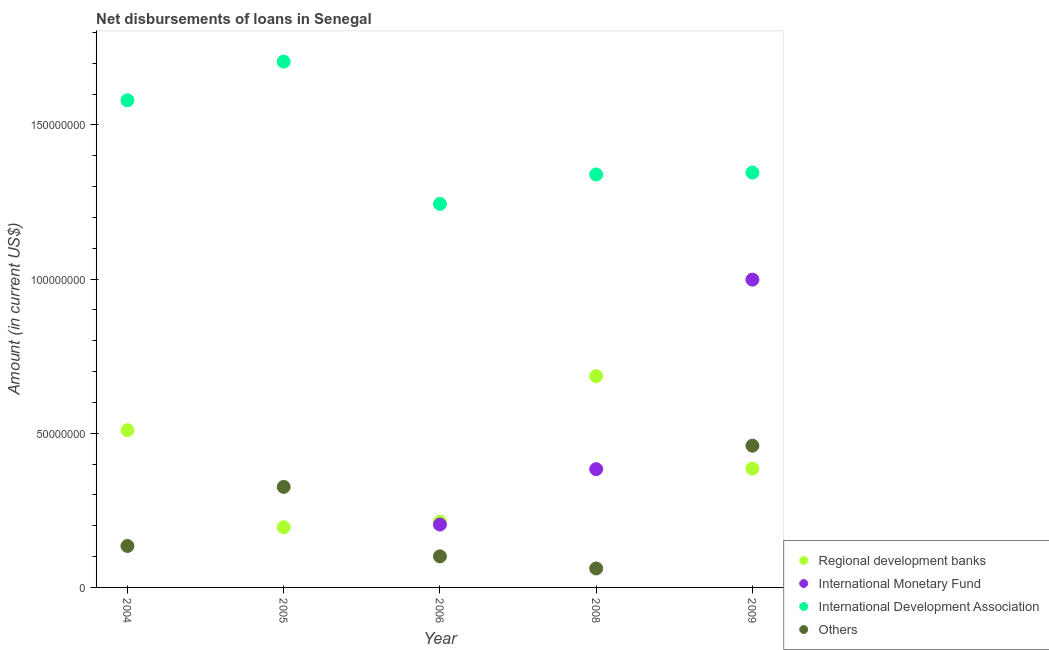What is the amount of loan disimbursed by international development association in 2008?
Ensure brevity in your answer.  1.34e+08. Across all years, what is the maximum amount of loan disimbursed by international development association?
Your answer should be compact. 1.71e+08. Across all years, what is the minimum amount of loan disimbursed by regional development banks?
Ensure brevity in your answer.  1.95e+07. In which year was the amount of loan disimbursed by international monetary fund maximum?
Ensure brevity in your answer.  2009. What is the total amount of loan disimbursed by other organisations in the graph?
Give a very brief answer. 1.08e+08. What is the difference between the amount of loan disimbursed by regional development banks in 2004 and that in 2008?
Offer a terse response. -1.75e+07. What is the difference between the amount of loan disimbursed by international monetary fund in 2006 and the amount of loan disimbursed by regional development banks in 2005?
Provide a short and direct response. 8.76e+05. What is the average amount of loan disimbursed by international development association per year?
Give a very brief answer. 1.44e+08. In the year 2006, what is the difference between the amount of loan disimbursed by other organisations and amount of loan disimbursed by international development association?
Offer a very short reply. -1.14e+08. What is the ratio of the amount of loan disimbursed by regional development banks in 2005 to that in 2006?
Ensure brevity in your answer.  0.92. Is the amount of loan disimbursed by international development association in 2005 less than that in 2008?
Give a very brief answer. No. Is the difference between the amount of loan disimbursed by other organisations in 2006 and 2008 greater than the difference between the amount of loan disimbursed by regional development banks in 2006 and 2008?
Your response must be concise. Yes. What is the difference between the highest and the second highest amount of loan disimbursed by other organisations?
Provide a short and direct response. 1.34e+07. What is the difference between the highest and the lowest amount of loan disimbursed by other organisations?
Your response must be concise. 3.98e+07. Is the amount of loan disimbursed by international development association strictly greater than the amount of loan disimbursed by other organisations over the years?
Keep it short and to the point. Yes. How many dotlines are there?
Provide a short and direct response. 4. Are the values on the major ticks of Y-axis written in scientific E-notation?
Give a very brief answer. No. Does the graph contain any zero values?
Ensure brevity in your answer.  Yes. Does the graph contain grids?
Ensure brevity in your answer.  No. Where does the legend appear in the graph?
Provide a succinct answer. Bottom right. How many legend labels are there?
Ensure brevity in your answer.  4. How are the legend labels stacked?
Offer a very short reply. Vertical. What is the title of the graph?
Give a very brief answer. Net disbursements of loans in Senegal. Does "Coal" appear as one of the legend labels in the graph?
Provide a short and direct response. No. What is the Amount (in current US$) of Regional development banks in 2004?
Provide a short and direct response. 5.10e+07. What is the Amount (in current US$) in International Development Association in 2004?
Provide a succinct answer. 1.58e+08. What is the Amount (in current US$) of Others in 2004?
Your answer should be very brief. 1.34e+07. What is the Amount (in current US$) of Regional development banks in 2005?
Your answer should be very brief. 1.95e+07. What is the Amount (in current US$) of International Development Association in 2005?
Provide a short and direct response. 1.71e+08. What is the Amount (in current US$) in Others in 2005?
Keep it short and to the point. 3.26e+07. What is the Amount (in current US$) in Regional development banks in 2006?
Give a very brief answer. 2.13e+07. What is the Amount (in current US$) in International Monetary Fund in 2006?
Provide a short and direct response. 2.04e+07. What is the Amount (in current US$) of International Development Association in 2006?
Your answer should be compact. 1.24e+08. What is the Amount (in current US$) of Others in 2006?
Your answer should be very brief. 1.01e+07. What is the Amount (in current US$) of Regional development banks in 2008?
Provide a succinct answer. 6.85e+07. What is the Amount (in current US$) of International Monetary Fund in 2008?
Give a very brief answer. 3.84e+07. What is the Amount (in current US$) of International Development Association in 2008?
Offer a terse response. 1.34e+08. What is the Amount (in current US$) in Others in 2008?
Your response must be concise. 6.15e+06. What is the Amount (in current US$) of Regional development banks in 2009?
Keep it short and to the point. 3.85e+07. What is the Amount (in current US$) in International Monetary Fund in 2009?
Your response must be concise. 9.98e+07. What is the Amount (in current US$) of International Development Association in 2009?
Provide a short and direct response. 1.35e+08. What is the Amount (in current US$) of Others in 2009?
Offer a terse response. 4.60e+07. Across all years, what is the maximum Amount (in current US$) in Regional development banks?
Your answer should be compact. 6.85e+07. Across all years, what is the maximum Amount (in current US$) in International Monetary Fund?
Your answer should be compact. 9.98e+07. Across all years, what is the maximum Amount (in current US$) in International Development Association?
Keep it short and to the point. 1.71e+08. Across all years, what is the maximum Amount (in current US$) in Others?
Ensure brevity in your answer.  4.60e+07. Across all years, what is the minimum Amount (in current US$) in Regional development banks?
Your answer should be compact. 1.95e+07. Across all years, what is the minimum Amount (in current US$) of International Development Association?
Offer a terse response. 1.24e+08. Across all years, what is the minimum Amount (in current US$) of Others?
Provide a short and direct response. 6.15e+06. What is the total Amount (in current US$) in Regional development banks in the graph?
Your answer should be very brief. 1.99e+08. What is the total Amount (in current US$) of International Monetary Fund in the graph?
Offer a terse response. 1.59e+08. What is the total Amount (in current US$) of International Development Association in the graph?
Make the answer very short. 7.21e+08. What is the total Amount (in current US$) in Others in the graph?
Provide a short and direct response. 1.08e+08. What is the difference between the Amount (in current US$) of Regional development banks in 2004 and that in 2005?
Your response must be concise. 3.15e+07. What is the difference between the Amount (in current US$) of International Development Association in 2004 and that in 2005?
Make the answer very short. -1.25e+07. What is the difference between the Amount (in current US$) in Others in 2004 and that in 2005?
Provide a short and direct response. -1.92e+07. What is the difference between the Amount (in current US$) in Regional development banks in 2004 and that in 2006?
Ensure brevity in your answer.  2.97e+07. What is the difference between the Amount (in current US$) of International Development Association in 2004 and that in 2006?
Ensure brevity in your answer.  3.36e+07. What is the difference between the Amount (in current US$) of Others in 2004 and that in 2006?
Give a very brief answer. 3.37e+06. What is the difference between the Amount (in current US$) in Regional development banks in 2004 and that in 2008?
Give a very brief answer. -1.75e+07. What is the difference between the Amount (in current US$) in International Development Association in 2004 and that in 2008?
Ensure brevity in your answer.  2.41e+07. What is the difference between the Amount (in current US$) of Others in 2004 and that in 2008?
Your answer should be very brief. 7.29e+06. What is the difference between the Amount (in current US$) of Regional development banks in 2004 and that in 2009?
Ensure brevity in your answer.  1.25e+07. What is the difference between the Amount (in current US$) of International Development Association in 2004 and that in 2009?
Give a very brief answer. 2.35e+07. What is the difference between the Amount (in current US$) in Others in 2004 and that in 2009?
Provide a short and direct response. -3.25e+07. What is the difference between the Amount (in current US$) of Regional development banks in 2005 and that in 2006?
Your answer should be very brief. -1.80e+06. What is the difference between the Amount (in current US$) in International Development Association in 2005 and that in 2006?
Ensure brevity in your answer.  4.61e+07. What is the difference between the Amount (in current US$) in Others in 2005 and that in 2006?
Your response must be concise. 2.25e+07. What is the difference between the Amount (in current US$) of Regional development banks in 2005 and that in 2008?
Offer a terse response. -4.90e+07. What is the difference between the Amount (in current US$) of International Development Association in 2005 and that in 2008?
Your answer should be compact. 3.66e+07. What is the difference between the Amount (in current US$) in Others in 2005 and that in 2008?
Make the answer very short. 2.65e+07. What is the difference between the Amount (in current US$) of Regional development banks in 2005 and that in 2009?
Provide a succinct answer. -1.90e+07. What is the difference between the Amount (in current US$) in International Development Association in 2005 and that in 2009?
Your answer should be compact. 3.60e+07. What is the difference between the Amount (in current US$) of Others in 2005 and that in 2009?
Your response must be concise. -1.34e+07. What is the difference between the Amount (in current US$) in Regional development banks in 2006 and that in 2008?
Keep it short and to the point. -4.72e+07. What is the difference between the Amount (in current US$) of International Monetary Fund in 2006 and that in 2008?
Provide a short and direct response. -1.80e+07. What is the difference between the Amount (in current US$) in International Development Association in 2006 and that in 2008?
Keep it short and to the point. -9.53e+06. What is the difference between the Amount (in current US$) of Others in 2006 and that in 2008?
Offer a very short reply. 3.92e+06. What is the difference between the Amount (in current US$) in Regional development banks in 2006 and that in 2009?
Your answer should be compact. -1.72e+07. What is the difference between the Amount (in current US$) in International Monetary Fund in 2006 and that in 2009?
Keep it short and to the point. -7.94e+07. What is the difference between the Amount (in current US$) of International Development Association in 2006 and that in 2009?
Provide a short and direct response. -1.01e+07. What is the difference between the Amount (in current US$) in Others in 2006 and that in 2009?
Provide a succinct answer. -3.59e+07. What is the difference between the Amount (in current US$) in Regional development banks in 2008 and that in 2009?
Offer a terse response. 3.00e+07. What is the difference between the Amount (in current US$) of International Monetary Fund in 2008 and that in 2009?
Ensure brevity in your answer.  -6.15e+07. What is the difference between the Amount (in current US$) of International Development Association in 2008 and that in 2009?
Keep it short and to the point. -6.13e+05. What is the difference between the Amount (in current US$) in Others in 2008 and that in 2009?
Provide a short and direct response. -3.98e+07. What is the difference between the Amount (in current US$) of Regional development banks in 2004 and the Amount (in current US$) of International Development Association in 2005?
Keep it short and to the point. -1.20e+08. What is the difference between the Amount (in current US$) of Regional development banks in 2004 and the Amount (in current US$) of Others in 2005?
Give a very brief answer. 1.84e+07. What is the difference between the Amount (in current US$) in International Development Association in 2004 and the Amount (in current US$) in Others in 2005?
Provide a succinct answer. 1.25e+08. What is the difference between the Amount (in current US$) in Regional development banks in 2004 and the Amount (in current US$) in International Monetary Fund in 2006?
Your answer should be very brief. 3.06e+07. What is the difference between the Amount (in current US$) in Regional development banks in 2004 and the Amount (in current US$) in International Development Association in 2006?
Your response must be concise. -7.34e+07. What is the difference between the Amount (in current US$) of Regional development banks in 2004 and the Amount (in current US$) of Others in 2006?
Offer a very short reply. 4.09e+07. What is the difference between the Amount (in current US$) in International Development Association in 2004 and the Amount (in current US$) in Others in 2006?
Your response must be concise. 1.48e+08. What is the difference between the Amount (in current US$) of Regional development banks in 2004 and the Amount (in current US$) of International Monetary Fund in 2008?
Provide a short and direct response. 1.26e+07. What is the difference between the Amount (in current US$) in Regional development banks in 2004 and the Amount (in current US$) in International Development Association in 2008?
Your answer should be very brief. -8.29e+07. What is the difference between the Amount (in current US$) in Regional development banks in 2004 and the Amount (in current US$) in Others in 2008?
Ensure brevity in your answer.  4.49e+07. What is the difference between the Amount (in current US$) of International Development Association in 2004 and the Amount (in current US$) of Others in 2008?
Your answer should be very brief. 1.52e+08. What is the difference between the Amount (in current US$) in Regional development banks in 2004 and the Amount (in current US$) in International Monetary Fund in 2009?
Offer a very short reply. -4.88e+07. What is the difference between the Amount (in current US$) of Regional development banks in 2004 and the Amount (in current US$) of International Development Association in 2009?
Your answer should be very brief. -8.35e+07. What is the difference between the Amount (in current US$) of Regional development banks in 2004 and the Amount (in current US$) of Others in 2009?
Your answer should be very brief. 5.04e+06. What is the difference between the Amount (in current US$) of International Development Association in 2004 and the Amount (in current US$) of Others in 2009?
Provide a succinct answer. 1.12e+08. What is the difference between the Amount (in current US$) of Regional development banks in 2005 and the Amount (in current US$) of International Monetary Fund in 2006?
Provide a short and direct response. -8.76e+05. What is the difference between the Amount (in current US$) of Regional development banks in 2005 and the Amount (in current US$) of International Development Association in 2006?
Keep it short and to the point. -1.05e+08. What is the difference between the Amount (in current US$) in Regional development banks in 2005 and the Amount (in current US$) in Others in 2006?
Offer a very short reply. 9.44e+06. What is the difference between the Amount (in current US$) in International Development Association in 2005 and the Amount (in current US$) in Others in 2006?
Provide a succinct answer. 1.60e+08. What is the difference between the Amount (in current US$) of Regional development banks in 2005 and the Amount (in current US$) of International Monetary Fund in 2008?
Provide a short and direct response. -1.88e+07. What is the difference between the Amount (in current US$) of Regional development banks in 2005 and the Amount (in current US$) of International Development Association in 2008?
Keep it short and to the point. -1.14e+08. What is the difference between the Amount (in current US$) in Regional development banks in 2005 and the Amount (in current US$) in Others in 2008?
Keep it short and to the point. 1.34e+07. What is the difference between the Amount (in current US$) of International Development Association in 2005 and the Amount (in current US$) of Others in 2008?
Ensure brevity in your answer.  1.64e+08. What is the difference between the Amount (in current US$) in Regional development banks in 2005 and the Amount (in current US$) in International Monetary Fund in 2009?
Make the answer very short. -8.03e+07. What is the difference between the Amount (in current US$) in Regional development banks in 2005 and the Amount (in current US$) in International Development Association in 2009?
Offer a terse response. -1.15e+08. What is the difference between the Amount (in current US$) of Regional development banks in 2005 and the Amount (in current US$) of Others in 2009?
Offer a terse response. -2.65e+07. What is the difference between the Amount (in current US$) of International Development Association in 2005 and the Amount (in current US$) of Others in 2009?
Provide a short and direct response. 1.25e+08. What is the difference between the Amount (in current US$) in Regional development banks in 2006 and the Amount (in current US$) in International Monetary Fund in 2008?
Make the answer very short. -1.70e+07. What is the difference between the Amount (in current US$) in Regional development banks in 2006 and the Amount (in current US$) in International Development Association in 2008?
Your response must be concise. -1.13e+08. What is the difference between the Amount (in current US$) in Regional development banks in 2006 and the Amount (in current US$) in Others in 2008?
Keep it short and to the point. 1.52e+07. What is the difference between the Amount (in current US$) of International Monetary Fund in 2006 and the Amount (in current US$) of International Development Association in 2008?
Your answer should be compact. -1.14e+08. What is the difference between the Amount (in current US$) in International Monetary Fund in 2006 and the Amount (in current US$) in Others in 2008?
Give a very brief answer. 1.42e+07. What is the difference between the Amount (in current US$) of International Development Association in 2006 and the Amount (in current US$) of Others in 2008?
Your answer should be very brief. 1.18e+08. What is the difference between the Amount (in current US$) of Regional development banks in 2006 and the Amount (in current US$) of International Monetary Fund in 2009?
Your answer should be compact. -7.85e+07. What is the difference between the Amount (in current US$) of Regional development banks in 2006 and the Amount (in current US$) of International Development Association in 2009?
Give a very brief answer. -1.13e+08. What is the difference between the Amount (in current US$) of Regional development banks in 2006 and the Amount (in current US$) of Others in 2009?
Offer a terse response. -2.46e+07. What is the difference between the Amount (in current US$) of International Monetary Fund in 2006 and the Amount (in current US$) of International Development Association in 2009?
Give a very brief answer. -1.14e+08. What is the difference between the Amount (in current US$) of International Monetary Fund in 2006 and the Amount (in current US$) of Others in 2009?
Offer a terse response. -2.56e+07. What is the difference between the Amount (in current US$) of International Development Association in 2006 and the Amount (in current US$) of Others in 2009?
Your answer should be very brief. 7.84e+07. What is the difference between the Amount (in current US$) in Regional development banks in 2008 and the Amount (in current US$) in International Monetary Fund in 2009?
Your answer should be compact. -3.13e+07. What is the difference between the Amount (in current US$) of Regional development banks in 2008 and the Amount (in current US$) of International Development Association in 2009?
Provide a succinct answer. -6.60e+07. What is the difference between the Amount (in current US$) in Regional development banks in 2008 and the Amount (in current US$) in Others in 2009?
Offer a terse response. 2.26e+07. What is the difference between the Amount (in current US$) of International Monetary Fund in 2008 and the Amount (in current US$) of International Development Association in 2009?
Provide a succinct answer. -9.62e+07. What is the difference between the Amount (in current US$) in International Monetary Fund in 2008 and the Amount (in current US$) in Others in 2009?
Your answer should be compact. -7.60e+06. What is the difference between the Amount (in current US$) in International Development Association in 2008 and the Amount (in current US$) in Others in 2009?
Your answer should be very brief. 8.80e+07. What is the average Amount (in current US$) in Regional development banks per year?
Make the answer very short. 3.98e+07. What is the average Amount (in current US$) in International Monetary Fund per year?
Make the answer very short. 3.17e+07. What is the average Amount (in current US$) of International Development Association per year?
Your answer should be very brief. 1.44e+08. What is the average Amount (in current US$) in Others per year?
Make the answer very short. 2.16e+07. In the year 2004, what is the difference between the Amount (in current US$) of Regional development banks and Amount (in current US$) of International Development Association?
Provide a succinct answer. -1.07e+08. In the year 2004, what is the difference between the Amount (in current US$) of Regional development banks and Amount (in current US$) of Others?
Your answer should be compact. 3.76e+07. In the year 2004, what is the difference between the Amount (in current US$) in International Development Association and Amount (in current US$) in Others?
Offer a very short reply. 1.45e+08. In the year 2005, what is the difference between the Amount (in current US$) of Regional development banks and Amount (in current US$) of International Development Association?
Your response must be concise. -1.51e+08. In the year 2005, what is the difference between the Amount (in current US$) in Regional development banks and Amount (in current US$) in Others?
Offer a very short reply. -1.31e+07. In the year 2005, what is the difference between the Amount (in current US$) of International Development Association and Amount (in current US$) of Others?
Keep it short and to the point. 1.38e+08. In the year 2006, what is the difference between the Amount (in current US$) in Regional development banks and Amount (in current US$) in International Monetary Fund?
Ensure brevity in your answer.  9.29e+05. In the year 2006, what is the difference between the Amount (in current US$) of Regional development banks and Amount (in current US$) of International Development Association?
Your response must be concise. -1.03e+08. In the year 2006, what is the difference between the Amount (in current US$) of Regional development banks and Amount (in current US$) of Others?
Your answer should be very brief. 1.12e+07. In the year 2006, what is the difference between the Amount (in current US$) of International Monetary Fund and Amount (in current US$) of International Development Association?
Give a very brief answer. -1.04e+08. In the year 2006, what is the difference between the Amount (in current US$) of International Monetary Fund and Amount (in current US$) of Others?
Provide a succinct answer. 1.03e+07. In the year 2006, what is the difference between the Amount (in current US$) in International Development Association and Amount (in current US$) in Others?
Your answer should be very brief. 1.14e+08. In the year 2008, what is the difference between the Amount (in current US$) of Regional development banks and Amount (in current US$) of International Monetary Fund?
Offer a very short reply. 3.02e+07. In the year 2008, what is the difference between the Amount (in current US$) of Regional development banks and Amount (in current US$) of International Development Association?
Provide a succinct answer. -6.54e+07. In the year 2008, what is the difference between the Amount (in current US$) of Regional development banks and Amount (in current US$) of Others?
Offer a very short reply. 6.24e+07. In the year 2008, what is the difference between the Amount (in current US$) in International Monetary Fund and Amount (in current US$) in International Development Association?
Your answer should be compact. -9.56e+07. In the year 2008, what is the difference between the Amount (in current US$) in International Monetary Fund and Amount (in current US$) in Others?
Your answer should be very brief. 3.22e+07. In the year 2008, what is the difference between the Amount (in current US$) in International Development Association and Amount (in current US$) in Others?
Ensure brevity in your answer.  1.28e+08. In the year 2009, what is the difference between the Amount (in current US$) of Regional development banks and Amount (in current US$) of International Monetary Fund?
Provide a succinct answer. -6.13e+07. In the year 2009, what is the difference between the Amount (in current US$) of Regional development banks and Amount (in current US$) of International Development Association?
Provide a succinct answer. -9.60e+07. In the year 2009, what is the difference between the Amount (in current US$) in Regional development banks and Amount (in current US$) in Others?
Give a very brief answer. -7.44e+06. In the year 2009, what is the difference between the Amount (in current US$) in International Monetary Fund and Amount (in current US$) in International Development Association?
Your answer should be compact. -3.47e+07. In the year 2009, what is the difference between the Amount (in current US$) in International Monetary Fund and Amount (in current US$) in Others?
Make the answer very short. 5.39e+07. In the year 2009, what is the difference between the Amount (in current US$) in International Development Association and Amount (in current US$) in Others?
Keep it short and to the point. 8.86e+07. What is the ratio of the Amount (in current US$) in Regional development banks in 2004 to that in 2005?
Your answer should be very brief. 2.61. What is the ratio of the Amount (in current US$) in International Development Association in 2004 to that in 2005?
Your answer should be compact. 0.93. What is the ratio of the Amount (in current US$) in Others in 2004 to that in 2005?
Provide a succinct answer. 0.41. What is the ratio of the Amount (in current US$) in Regional development banks in 2004 to that in 2006?
Ensure brevity in your answer.  2.39. What is the ratio of the Amount (in current US$) in International Development Association in 2004 to that in 2006?
Keep it short and to the point. 1.27. What is the ratio of the Amount (in current US$) in Others in 2004 to that in 2006?
Provide a short and direct response. 1.33. What is the ratio of the Amount (in current US$) in Regional development banks in 2004 to that in 2008?
Your answer should be very brief. 0.74. What is the ratio of the Amount (in current US$) in International Development Association in 2004 to that in 2008?
Make the answer very short. 1.18. What is the ratio of the Amount (in current US$) in Others in 2004 to that in 2008?
Give a very brief answer. 2.18. What is the ratio of the Amount (in current US$) in Regional development banks in 2004 to that in 2009?
Provide a succinct answer. 1.32. What is the ratio of the Amount (in current US$) of International Development Association in 2004 to that in 2009?
Provide a short and direct response. 1.17. What is the ratio of the Amount (in current US$) of Others in 2004 to that in 2009?
Keep it short and to the point. 0.29. What is the ratio of the Amount (in current US$) in Regional development banks in 2005 to that in 2006?
Offer a very short reply. 0.92. What is the ratio of the Amount (in current US$) in International Development Association in 2005 to that in 2006?
Offer a very short reply. 1.37. What is the ratio of the Amount (in current US$) of Others in 2005 to that in 2006?
Your answer should be compact. 3.24. What is the ratio of the Amount (in current US$) of Regional development banks in 2005 to that in 2008?
Offer a very short reply. 0.28. What is the ratio of the Amount (in current US$) of International Development Association in 2005 to that in 2008?
Make the answer very short. 1.27. What is the ratio of the Amount (in current US$) of Others in 2005 to that in 2008?
Provide a succinct answer. 5.3. What is the ratio of the Amount (in current US$) in Regional development banks in 2005 to that in 2009?
Keep it short and to the point. 0.51. What is the ratio of the Amount (in current US$) of International Development Association in 2005 to that in 2009?
Keep it short and to the point. 1.27. What is the ratio of the Amount (in current US$) in Others in 2005 to that in 2009?
Give a very brief answer. 0.71. What is the ratio of the Amount (in current US$) in Regional development banks in 2006 to that in 2008?
Provide a short and direct response. 0.31. What is the ratio of the Amount (in current US$) in International Monetary Fund in 2006 to that in 2008?
Provide a succinct answer. 0.53. What is the ratio of the Amount (in current US$) in International Development Association in 2006 to that in 2008?
Your answer should be compact. 0.93. What is the ratio of the Amount (in current US$) of Others in 2006 to that in 2008?
Provide a succinct answer. 1.64. What is the ratio of the Amount (in current US$) of Regional development banks in 2006 to that in 2009?
Your answer should be compact. 0.55. What is the ratio of the Amount (in current US$) of International Monetary Fund in 2006 to that in 2009?
Your answer should be compact. 0.2. What is the ratio of the Amount (in current US$) in International Development Association in 2006 to that in 2009?
Give a very brief answer. 0.92. What is the ratio of the Amount (in current US$) of Others in 2006 to that in 2009?
Your answer should be compact. 0.22. What is the ratio of the Amount (in current US$) of Regional development banks in 2008 to that in 2009?
Offer a terse response. 1.78. What is the ratio of the Amount (in current US$) of International Monetary Fund in 2008 to that in 2009?
Make the answer very short. 0.38. What is the ratio of the Amount (in current US$) in Others in 2008 to that in 2009?
Give a very brief answer. 0.13. What is the difference between the highest and the second highest Amount (in current US$) of Regional development banks?
Your answer should be compact. 1.75e+07. What is the difference between the highest and the second highest Amount (in current US$) in International Monetary Fund?
Keep it short and to the point. 6.15e+07. What is the difference between the highest and the second highest Amount (in current US$) of International Development Association?
Provide a succinct answer. 1.25e+07. What is the difference between the highest and the second highest Amount (in current US$) in Others?
Your answer should be very brief. 1.34e+07. What is the difference between the highest and the lowest Amount (in current US$) of Regional development banks?
Offer a terse response. 4.90e+07. What is the difference between the highest and the lowest Amount (in current US$) of International Monetary Fund?
Give a very brief answer. 9.98e+07. What is the difference between the highest and the lowest Amount (in current US$) of International Development Association?
Offer a terse response. 4.61e+07. What is the difference between the highest and the lowest Amount (in current US$) in Others?
Make the answer very short. 3.98e+07. 